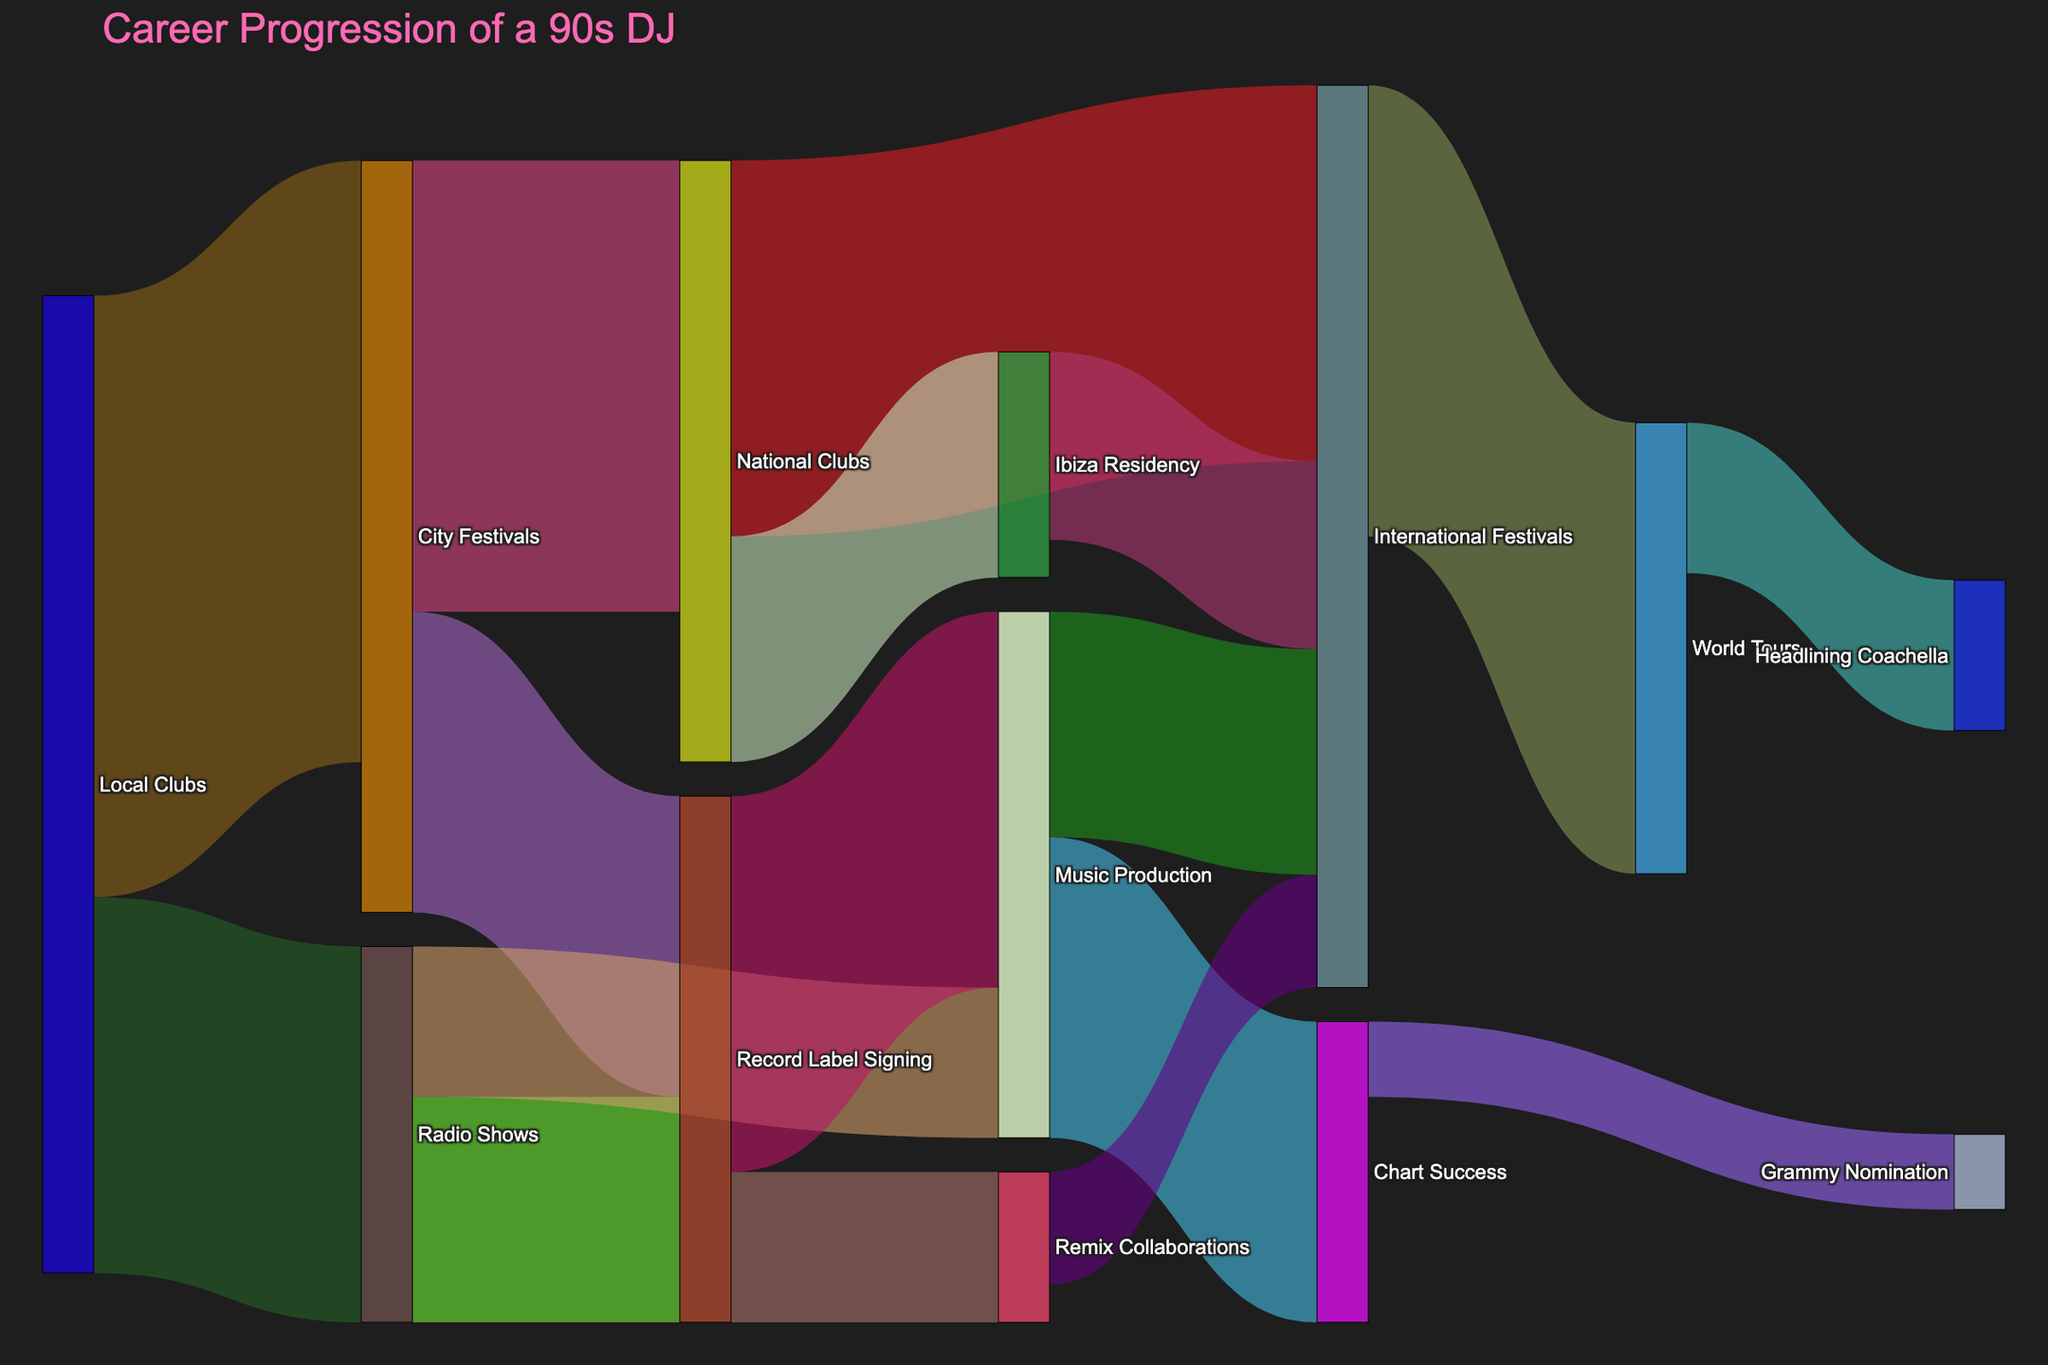Which node has the highest outgoing value? By visually inspecting the width of the flows coming out of each node, we see that the 'Local Clubs' node has two outgoing links summing up to 130 (80+50), which is the highest.
Answer: Local Clubs What is the total value of DJs progressing from City Festivals to other nodes? To find this, we sum up the values from City Festivals to National Clubs (60) and City Festivals to Record Label Signing (40), giving us a total of 100.
Answer: 100 Which event has the most incoming links and how many are there? By checking the width of flows and connections to each node, 'International Festivals' receives values from National Clubs (50), Music Production (30), Remix Collaborations (15), and Ibiza Residency (25), totaling 4 incoming links.
Answer: International Festivals, 4 What is the total value flowing into 'Music Production'? To determine this, sum the incoming values from Radio Shows (20) and Record Label Signing (50), resulting in 70.
Answer: 70 Compare the value flowing from DJs' 'Radio Shows' experiences to 'Record Label Signing' vs. the value flowing from 'City Festivals' to 'Record Label Signing'. The value from Radio Shows to Record Label Signing is 30, while from City Festivals to Record Label Signing it is 40, so the flow from City Festivals is higher.
Answer: City Festivals has a higher flow Which node has the highest value accumulating both incoming and outgoing values? Sum the incoming and outgoing values for each node. For 'International Festivals': incoming (50+30+15+25=120) and outgoing (60), total accumulation = 180. This is the highest among all nodes.
Answer: International Festivals How many total value flows into 'Chart Success'? 'Chart Success' has a single incoming flow from 'Music Production' with a value of 40.
Answer: 40 What is the total value flowing into 'World Tours' from various sources? 'World Tours' receives a single flow from 'International Festivals' with a value of 60.
Answer: 60 Calculate the sum of values progressing from 'Record Label Signing' to 'Music Production' and 'Remix Collaborations'. The total adds up to the value to 'Music Production' (50) plus the value to 'Remix Collaborations' (20), resulting in 70.
Answer: 70 Which has a higher value, the flow from 'Local Clubs' to 'City Festivals' or from 'National Clubs' to 'Ibiza Residency'? Visually compare the flow values: from 'Local Clubs' to 'City Festivals' is 80, while from 'National Clubs' to 'Ibiza Residency' is 30. The first flow is higher.
Answer: Local Clubs to City Festivals 